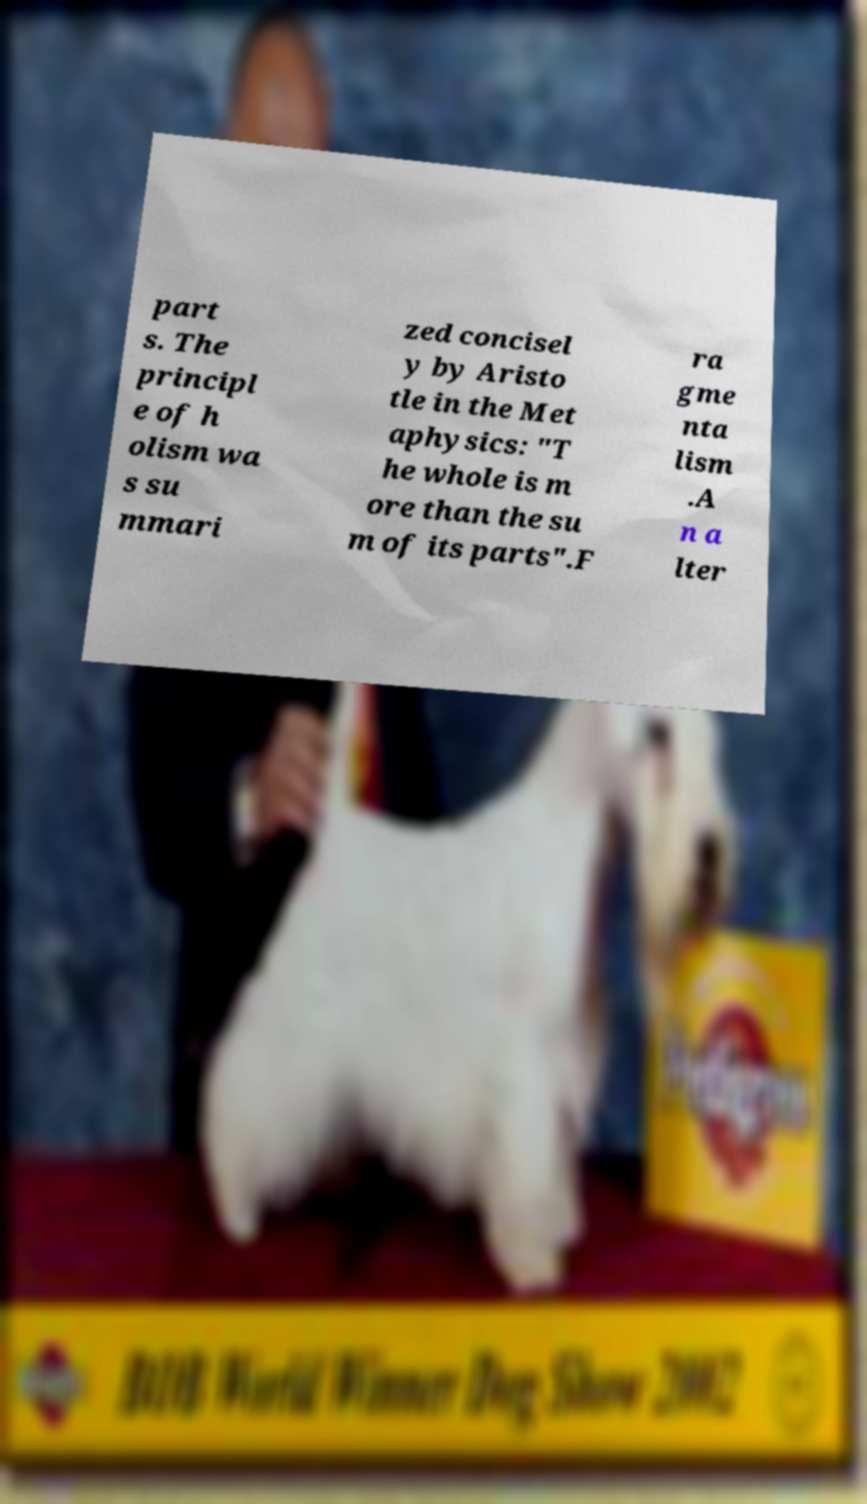Please identify and transcribe the text found in this image. part s. The principl e of h olism wa s su mmari zed concisel y by Aristo tle in the Met aphysics: "T he whole is m ore than the su m of its parts".F ra gme nta lism .A n a lter 